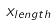Convert formula to latex. <formula><loc_0><loc_0><loc_500><loc_500>x _ { l e n g t h }</formula> 